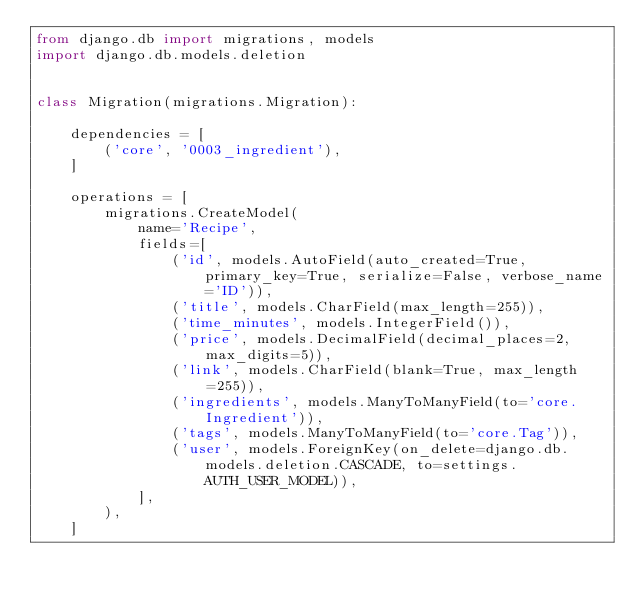<code> <loc_0><loc_0><loc_500><loc_500><_Python_>from django.db import migrations, models
import django.db.models.deletion


class Migration(migrations.Migration):

    dependencies = [
        ('core', '0003_ingredient'),
    ]

    operations = [
        migrations.CreateModel(
            name='Recipe',
            fields=[
                ('id', models.AutoField(auto_created=True, primary_key=True, serialize=False, verbose_name='ID')),
                ('title', models.CharField(max_length=255)),
                ('time_minutes', models.IntegerField()),
                ('price', models.DecimalField(decimal_places=2, max_digits=5)),
                ('link', models.CharField(blank=True, max_length=255)),
                ('ingredients', models.ManyToManyField(to='core.Ingredient')),
                ('tags', models.ManyToManyField(to='core.Tag')),
                ('user', models.ForeignKey(on_delete=django.db.models.deletion.CASCADE, to=settings.AUTH_USER_MODEL)),
            ],
        ),
    ]
</code> 